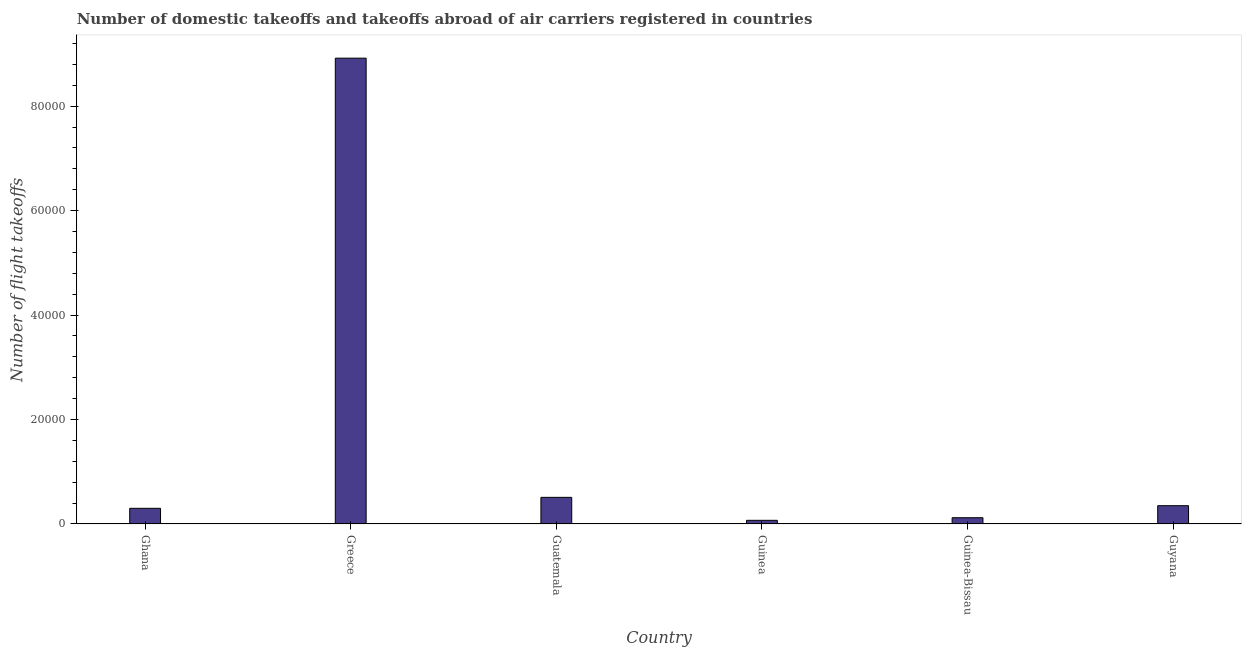Does the graph contain grids?
Keep it short and to the point. No. What is the title of the graph?
Your answer should be very brief. Number of domestic takeoffs and takeoffs abroad of air carriers registered in countries. What is the label or title of the Y-axis?
Keep it short and to the point. Number of flight takeoffs. What is the number of flight takeoffs in Guatemala?
Provide a succinct answer. 5100. Across all countries, what is the maximum number of flight takeoffs?
Offer a terse response. 8.92e+04. Across all countries, what is the minimum number of flight takeoffs?
Offer a very short reply. 700. In which country was the number of flight takeoffs minimum?
Your response must be concise. Guinea. What is the sum of the number of flight takeoffs?
Your answer should be very brief. 1.03e+05. What is the difference between the number of flight takeoffs in Ghana and Guatemala?
Your answer should be very brief. -2100. What is the average number of flight takeoffs per country?
Keep it short and to the point. 1.71e+04. What is the median number of flight takeoffs?
Offer a terse response. 3250. What is the ratio of the number of flight takeoffs in Guatemala to that in Guyana?
Provide a succinct answer. 1.46. Is the difference between the number of flight takeoffs in Greece and Guinea greater than the difference between any two countries?
Keep it short and to the point. Yes. What is the difference between the highest and the second highest number of flight takeoffs?
Give a very brief answer. 8.41e+04. What is the difference between the highest and the lowest number of flight takeoffs?
Provide a succinct answer. 8.85e+04. In how many countries, is the number of flight takeoffs greater than the average number of flight takeoffs taken over all countries?
Make the answer very short. 1. How many bars are there?
Keep it short and to the point. 6. Are all the bars in the graph horizontal?
Your answer should be compact. No. How many countries are there in the graph?
Your response must be concise. 6. What is the difference between two consecutive major ticks on the Y-axis?
Offer a terse response. 2.00e+04. Are the values on the major ticks of Y-axis written in scientific E-notation?
Your response must be concise. No. What is the Number of flight takeoffs in Ghana?
Make the answer very short. 3000. What is the Number of flight takeoffs of Greece?
Your response must be concise. 8.92e+04. What is the Number of flight takeoffs in Guatemala?
Provide a short and direct response. 5100. What is the Number of flight takeoffs of Guinea?
Your answer should be very brief. 700. What is the Number of flight takeoffs of Guinea-Bissau?
Offer a very short reply. 1200. What is the Number of flight takeoffs in Guyana?
Your answer should be compact. 3500. What is the difference between the Number of flight takeoffs in Ghana and Greece?
Your answer should be very brief. -8.62e+04. What is the difference between the Number of flight takeoffs in Ghana and Guatemala?
Your answer should be very brief. -2100. What is the difference between the Number of flight takeoffs in Ghana and Guinea?
Provide a succinct answer. 2300. What is the difference between the Number of flight takeoffs in Ghana and Guinea-Bissau?
Offer a very short reply. 1800. What is the difference between the Number of flight takeoffs in Ghana and Guyana?
Keep it short and to the point. -500. What is the difference between the Number of flight takeoffs in Greece and Guatemala?
Ensure brevity in your answer.  8.41e+04. What is the difference between the Number of flight takeoffs in Greece and Guinea?
Offer a very short reply. 8.85e+04. What is the difference between the Number of flight takeoffs in Greece and Guinea-Bissau?
Make the answer very short. 8.80e+04. What is the difference between the Number of flight takeoffs in Greece and Guyana?
Keep it short and to the point. 8.57e+04. What is the difference between the Number of flight takeoffs in Guatemala and Guinea?
Your response must be concise. 4400. What is the difference between the Number of flight takeoffs in Guatemala and Guinea-Bissau?
Make the answer very short. 3900. What is the difference between the Number of flight takeoffs in Guatemala and Guyana?
Your response must be concise. 1600. What is the difference between the Number of flight takeoffs in Guinea and Guinea-Bissau?
Your answer should be compact. -500. What is the difference between the Number of flight takeoffs in Guinea and Guyana?
Ensure brevity in your answer.  -2800. What is the difference between the Number of flight takeoffs in Guinea-Bissau and Guyana?
Keep it short and to the point. -2300. What is the ratio of the Number of flight takeoffs in Ghana to that in Greece?
Keep it short and to the point. 0.03. What is the ratio of the Number of flight takeoffs in Ghana to that in Guatemala?
Offer a terse response. 0.59. What is the ratio of the Number of flight takeoffs in Ghana to that in Guinea?
Offer a terse response. 4.29. What is the ratio of the Number of flight takeoffs in Ghana to that in Guyana?
Keep it short and to the point. 0.86. What is the ratio of the Number of flight takeoffs in Greece to that in Guatemala?
Ensure brevity in your answer.  17.49. What is the ratio of the Number of flight takeoffs in Greece to that in Guinea?
Provide a short and direct response. 127.43. What is the ratio of the Number of flight takeoffs in Greece to that in Guinea-Bissau?
Your response must be concise. 74.33. What is the ratio of the Number of flight takeoffs in Greece to that in Guyana?
Your answer should be compact. 25.49. What is the ratio of the Number of flight takeoffs in Guatemala to that in Guinea?
Ensure brevity in your answer.  7.29. What is the ratio of the Number of flight takeoffs in Guatemala to that in Guinea-Bissau?
Make the answer very short. 4.25. What is the ratio of the Number of flight takeoffs in Guatemala to that in Guyana?
Ensure brevity in your answer.  1.46. What is the ratio of the Number of flight takeoffs in Guinea to that in Guinea-Bissau?
Provide a succinct answer. 0.58. What is the ratio of the Number of flight takeoffs in Guinea-Bissau to that in Guyana?
Ensure brevity in your answer.  0.34. 